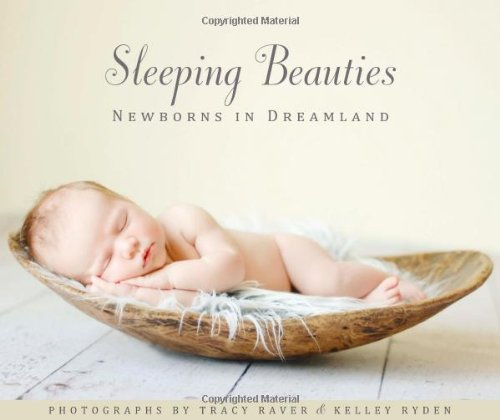Is this an art related book? Yes, it is an art-related book, showcasing the delicate and artistic portrayal of newborns through professional photography. 